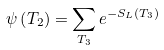<formula> <loc_0><loc_0><loc_500><loc_500>\psi \left ( T _ { 2 } \right ) = \sum _ { T _ { 3 } } e ^ { - S _ { L } \left ( T _ { 3 } \right ) }</formula> 